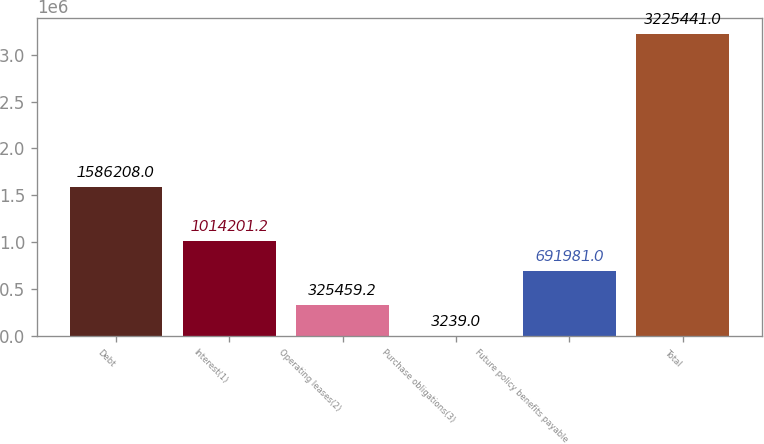<chart> <loc_0><loc_0><loc_500><loc_500><bar_chart><fcel>Debt<fcel>Interest(1)<fcel>Operating leases(2)<fcel>Purchase obligations(3)<fcel>Future policy benefits payable<fcel>Total<nl><fcel>1.58621e+06<fcel>1.0142e+06<fcel>325459<fcel>3239<fcel>691981<fcel>3.22544e+06<nl></chart> 